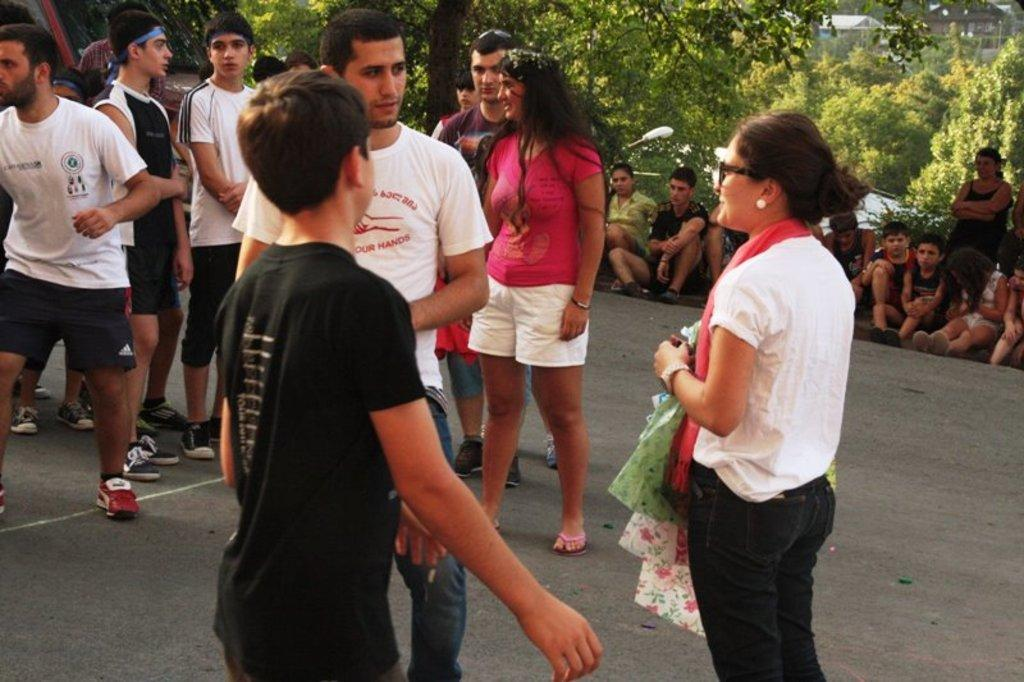What can be seen in the foreground of the image? There are people in the foreground of the image. What are some of the people doing in the image? Some people are sitting. What can be seen in the background of the image? There are trees, houses, and a lamp pole in the background of the image. What type of operation is being performed by the maid in the image? There is no maid present in the image, and therefore no operation is being performed. 